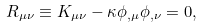<formula> <loc_0><loc_0><loc_500><loc_500>R _ { \mu \nu } \equiv K _ { \mu \nu } - \kappa \phi _ { , \mu } \phi _ { , \nu } = 0 ,</formula> 